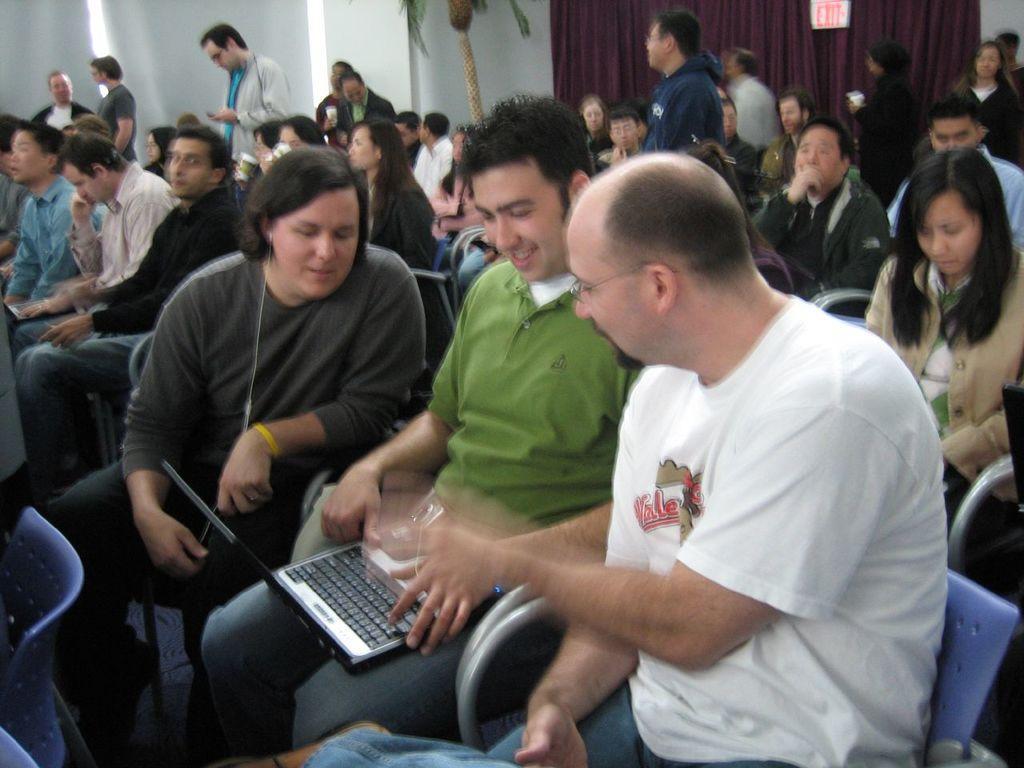In one or two sentences, can you explain what this image depicts? In this image a person wearing a green T- shirt is sitting on the chair. He is having laptop on his lap. Beside him there is a person wearing white T-shirt is sitting on the chair. Behind them there are few persons sitting on the chair. Few persons are standing on the floor. Top of the image there is a plant. Beside there is a curtain. Background there is a wall. 